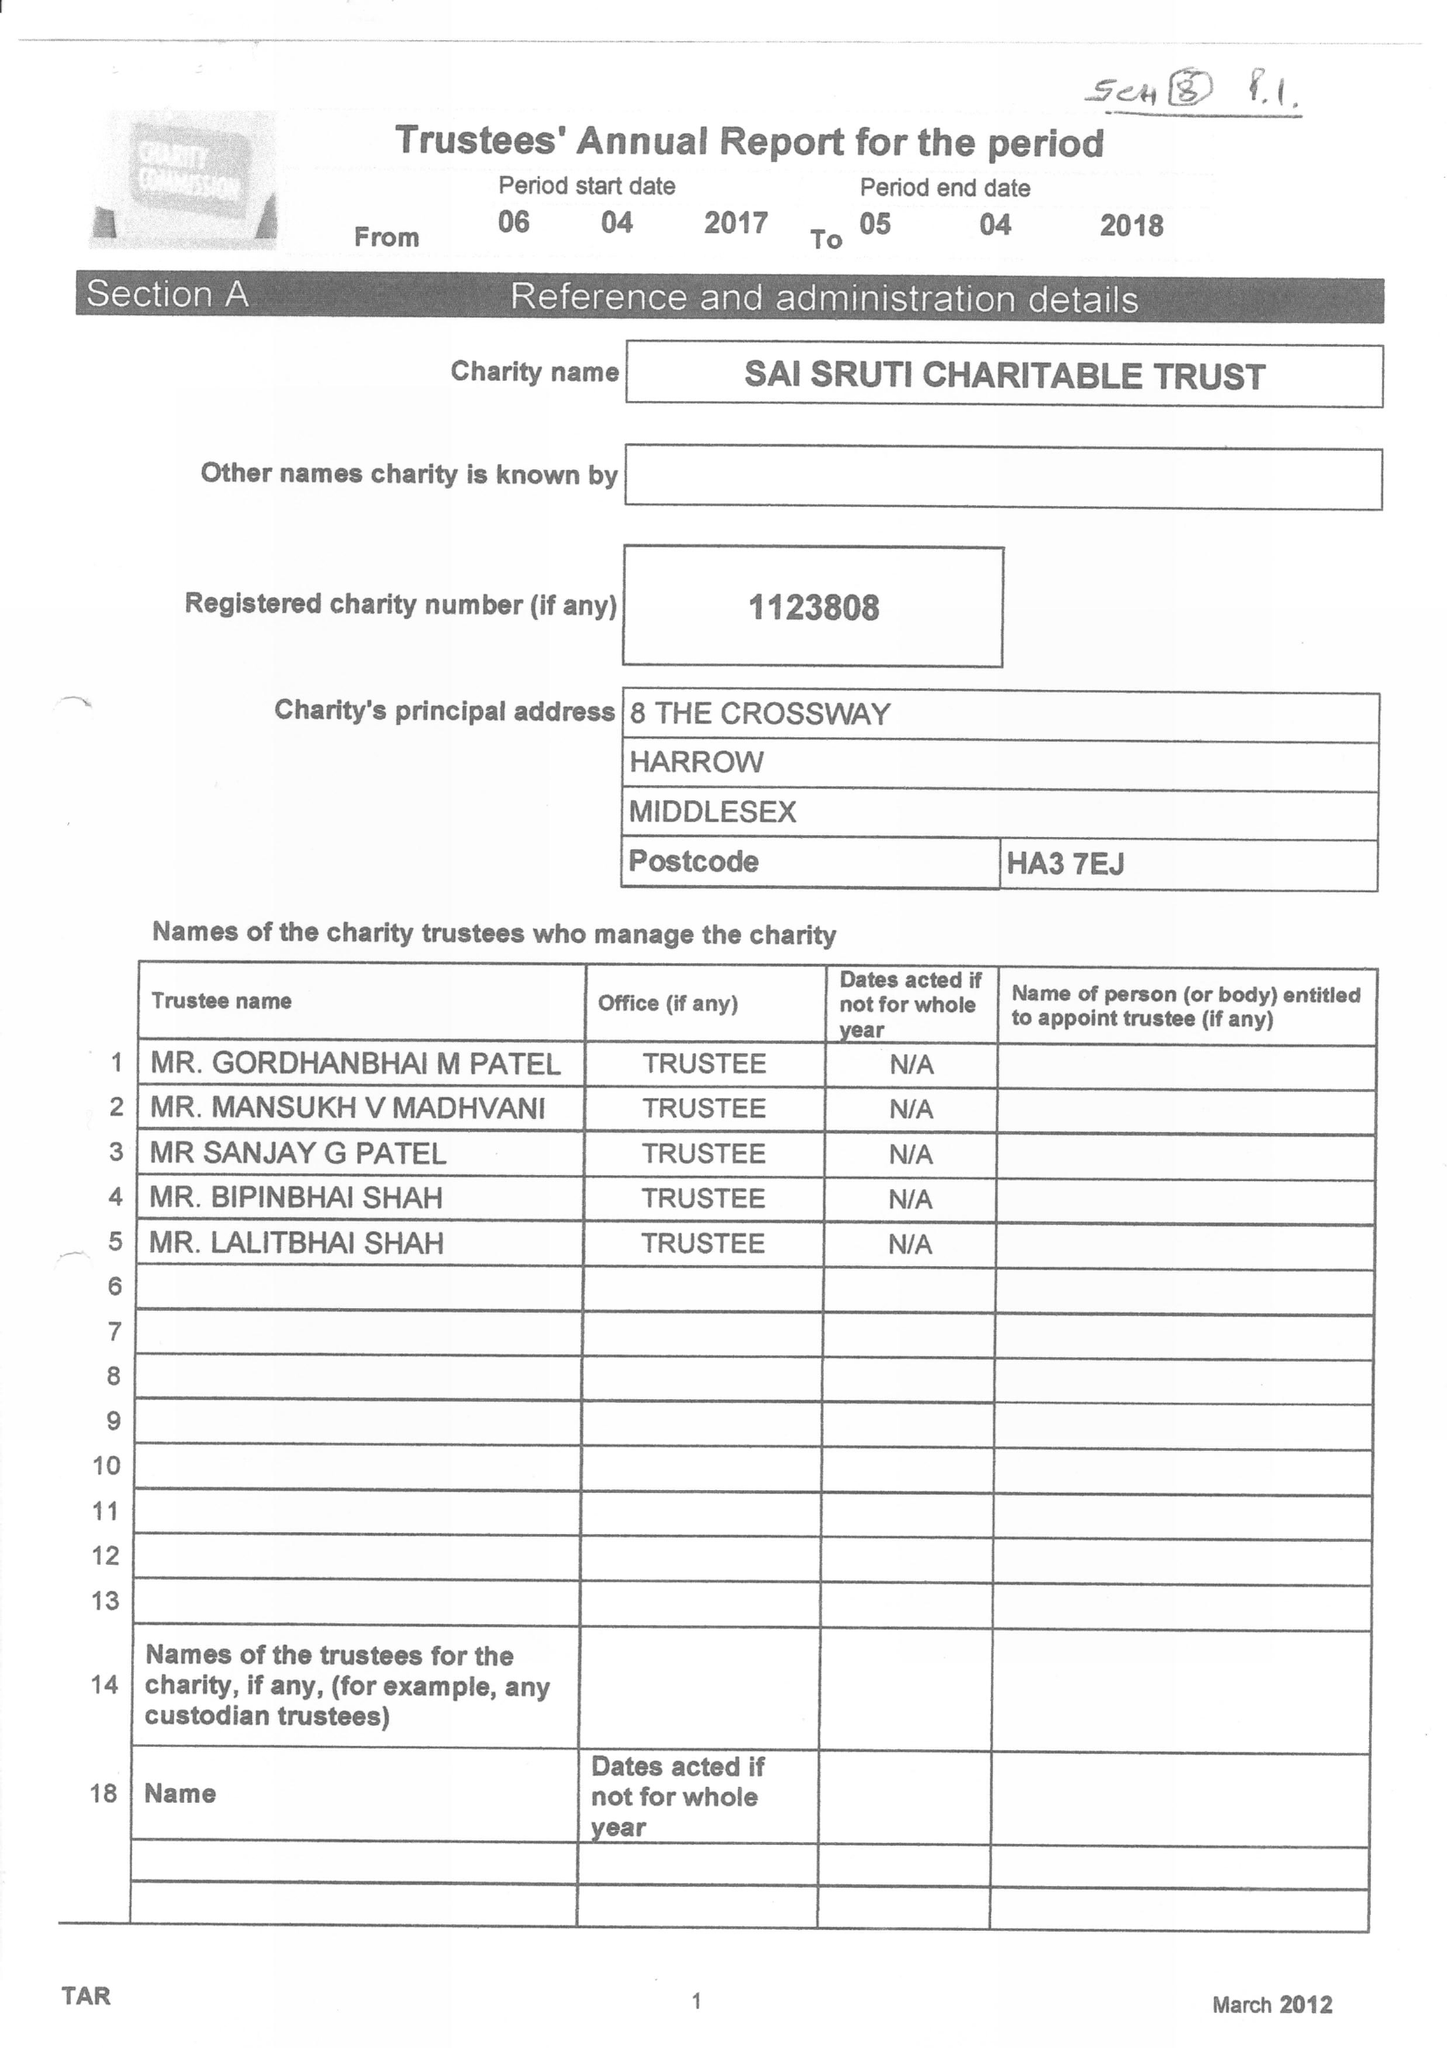What is the value for the report_date?
Answer the question using a single word or phrase. 2018-04-05 